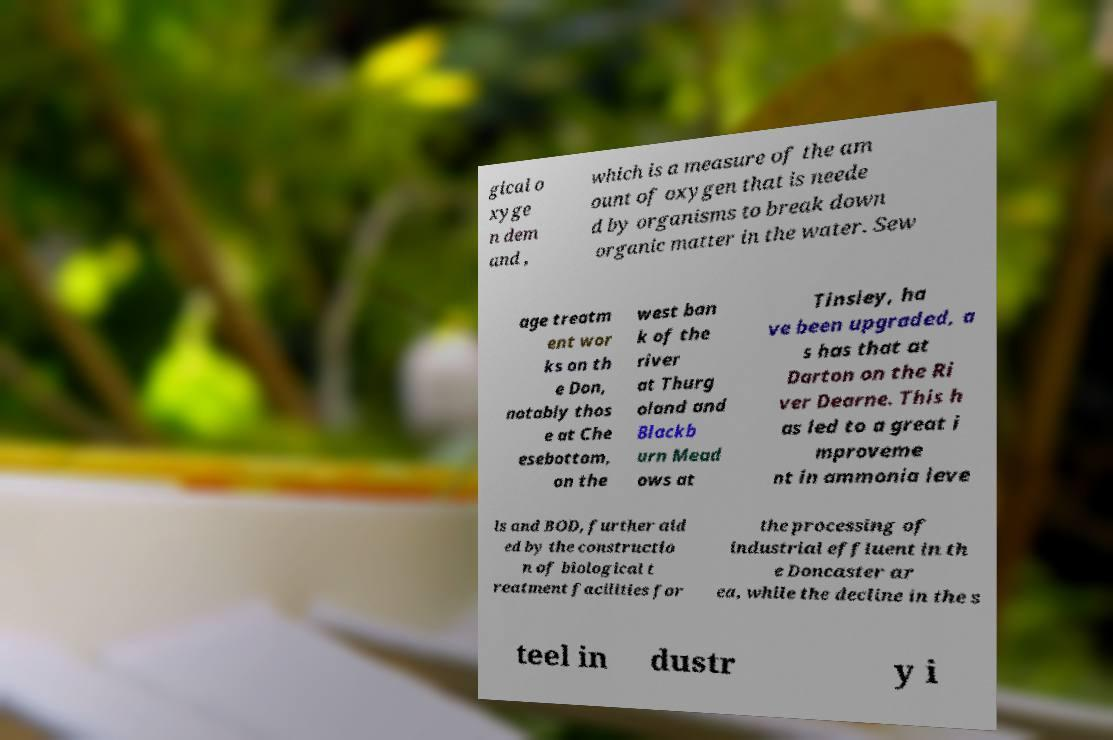Please read and relay the text visible in this image. What does it say? gical o xyge n dem and , which is a measure of the am ount of oxygen that is neede d by organisms to break down organic matter in the water. Sew age treatm ent wor ks on th e Don, notably thos e at Che esebottom, on the west ban k of the river at Thurg oland and Blackb urn Mead ows at Tinsley, ha ve been upgraded, a s has that at Darton on the Ri ver Dearne. This h as led to a great i mproveme nt in ammonia leve ls and BOD, further aid ed by the constructio n of biological t reatment facilities for the processing of industrial effluent in th e Doncaster ar ea, while the decline in the s teel in dustr y i 